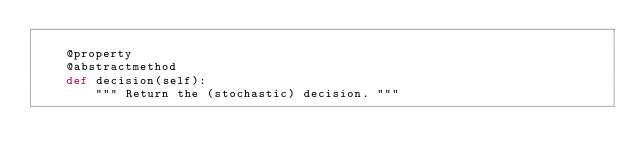Convert code to text. <code><loc_0><loc_0><loc_500><loc_500><_Python_>
    @property
    @abstractmethod
    def decision(self):
        """ Return the (stochastic) decision. """
</code> 